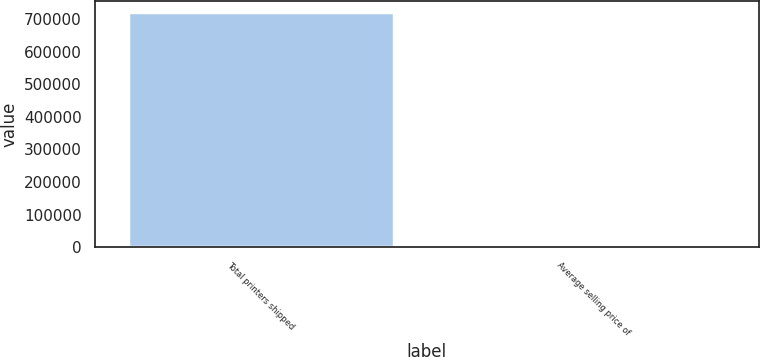Convert chart to OTSL. <chart><loc_0><loc_0><loc_500><loc_500><bar_chart><fcel>Total printers shipped<fcel>Average selling price of<nl><fcel>719576<fcel>629<nl></chart> 